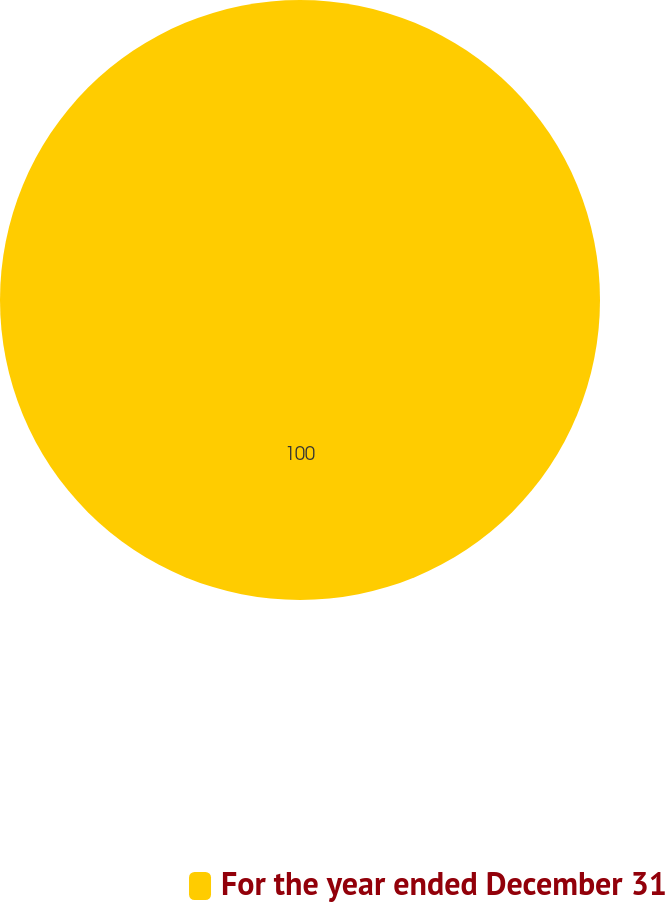Convert chart. <chart><loc_0><loc_0><loc_500><loc_500><pie_chart><fcel>For the year ended December 31<nl><fcel>100.0%<nl></chart> 